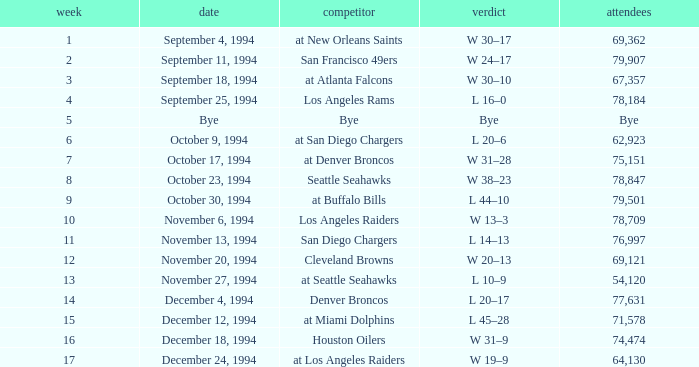What was the score of the Chiefs pre-Week 16 game that 69,362 people attended? W 30–17. 